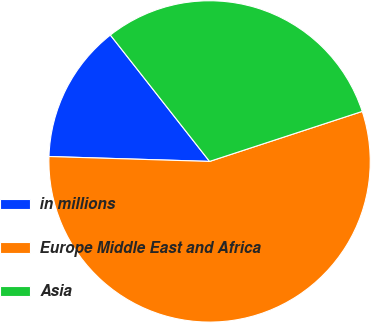Convert chart. <chart><loc_0><loc_0><loc_500><loc_500><pie_chart><fcel>in millions<fcel>Europe Middle East and Africa<fcel>Asia<nl><fcel>13.92%<fcel>55.52%<fcel>30.55%<nl></chart> 